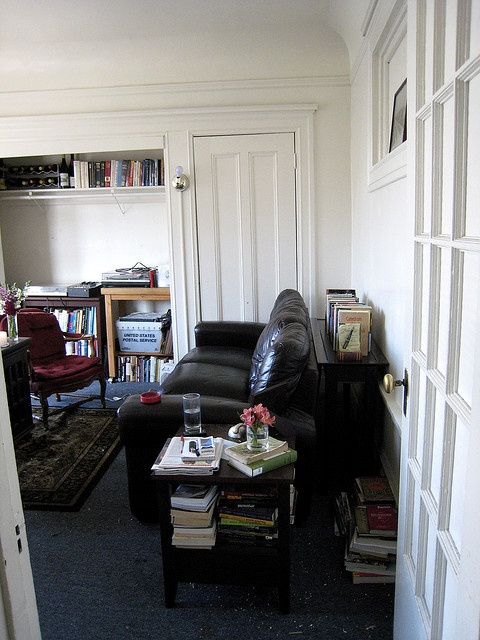Describe the objects in this image and their specific colors. I can see book in lightgray, black, gray, and darkgray tones, couch in lightgray, black, and gray tones, chair in lightgray, black, maroon, and gray tones, book in lightgray, black, gray, and maroon tones, and book in lightgray, black, and gray tones in this image. 